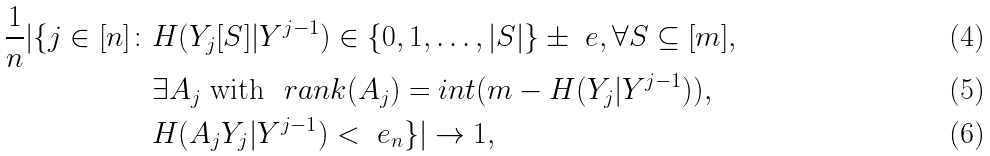<formula> <loc_0><loc_0><loc_500><loc_500>\frac { 1 } { n } | \{ j \in [ n ] \colon & H ( Y _ { j } [ S ] | Y ^ { j - 1 } ) \in \{ 0 , 1 , \dots , | S | \} \pm \ e , \forall S \subseteq [ m ] , \\ & \exists A _ { j } \text { with } \ r a n k ( A _ { j } ) = i n t ( m - H ( Y _ { j } | Y ^ { j - 1 } ) ) , \\ & H ( A _ { j } Y _ { j } | Y ^ { j - 1 } ) < \ e _ { n } \} | \to 1 ,</formula> 